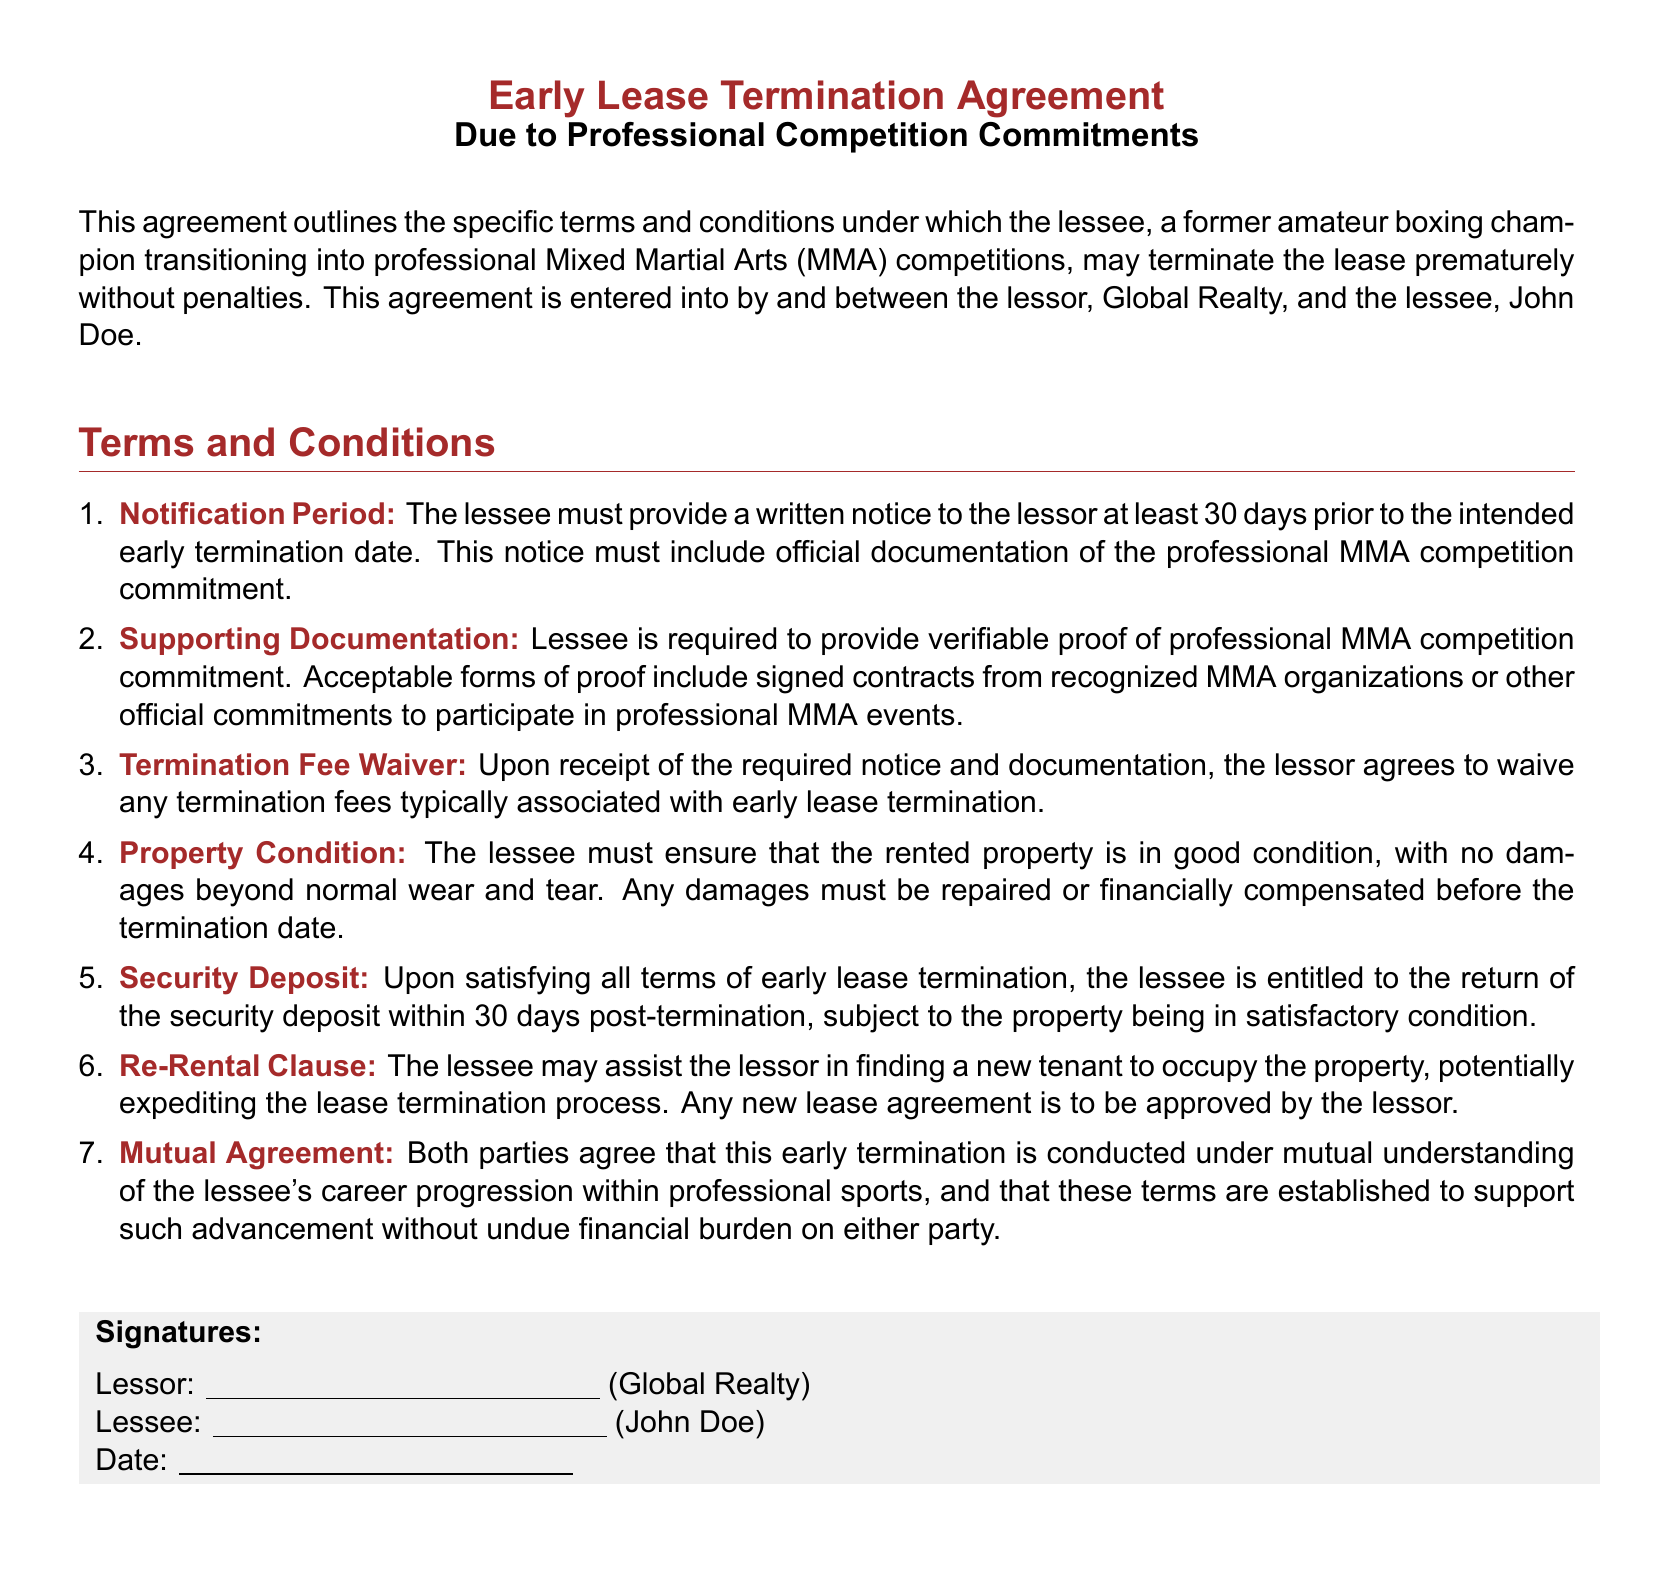What is the notification period required for early lease termination? The notification period specified in the document is at least 30 days prior to the intended early termination date.
Answer: 30 days What documentation must the lessee provide? The document states that the lessee must provide official documentation of the professional MMA competition commitment.
Answer: Official documentation What fees are waived upon notification and documentation receipt? The document mentions that any termination fees typically associated with early lease termination are waived.
Answer: Termination fees What condition must the rented property be in upon termination? According to the document, the rented property must be in good condition, with no damages beyond normal wear and tear.
Answer: Good condition When is the security deposit returned to the lessee? The security deposit is to be returned within 30 days post-termination, subject to property condition.
Answer: 30 days What does the lessee have the option to do regarding finding a new tenant? The document allows the lessee to assist the lessor in finding a new tenant for the property.
Answer: Assist in finding a new tenant What mutual understanding do both parties establish in the document? The document specifies that the mutual understanding relates to the lessee's career progression within professional sports.
Answer: Career progression Who are the parties involved in this lease termination agreement? The parties involved in the agreement are the lessor, Global Realty, and the lessee, John Doe.
Answer: Global Realty and John Doe 